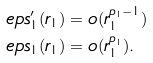Convert formula to latex. <formula><loc_0><loc_0><loc_500><loc_500>\ e p s ^ { \prime } _ { 1 } ( r _ { 1 } ) & = o ( r _ { 1 } ^ { p _ { 1 } - 1 } ) \\ \ e p s _ { 1 } ( r _ { 1 } ) & = o ( r _ { 1 } ^ { p _ { 1 } } ) .</formula> 